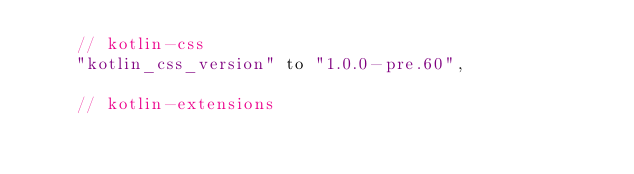<code> <loc_0><loc_0><loc_500><loc_500><_Kotlin_>    // kotlin-css
    "kotlin_css_version" to "1.0.0-pre.60",

    // kotlin-extensions</code> 